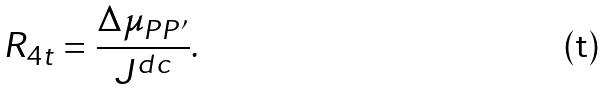<formula> <loc_0><loc_0><loc_500><loc_500>R _ { 4 t } = \frac { \Delta \mu _ { P P ^ { \prime } } } { J ^ { d c } } .</formula> 